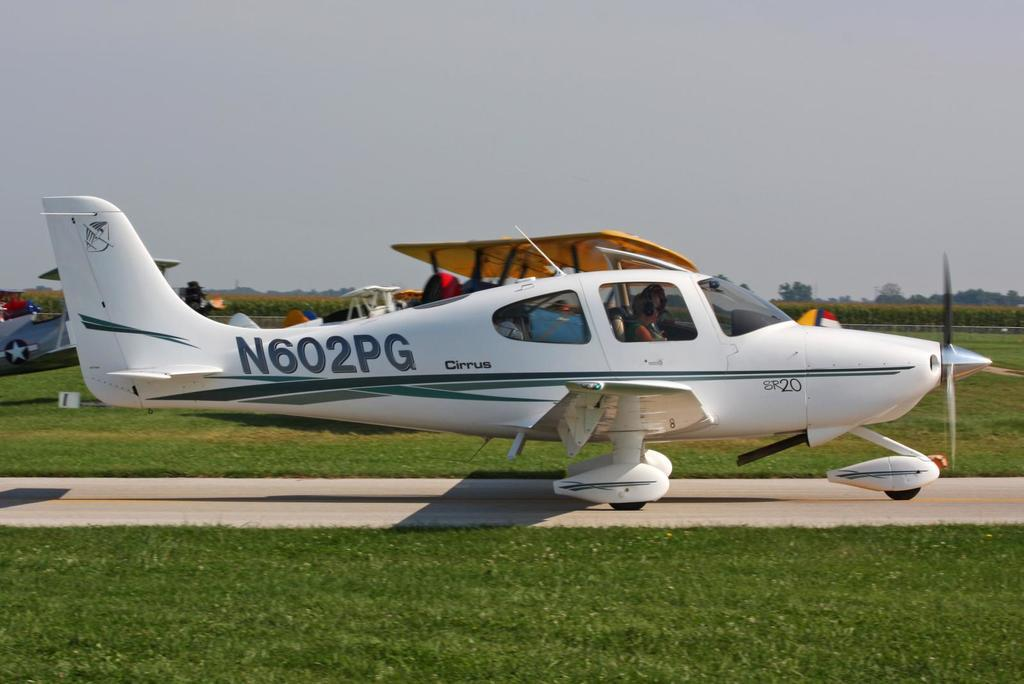What can be seen on the runway in the image? There are aeroplanes on the runway in the image. What are the people in the image doing? There are persons sitting in the seats of one of the aeroplanes. What type of natural environment is visible in the background of the image? Trees and agricultural farms are visible in the background of the image. What is visible in the sky in the image? The sky is visible in the background of the image. What type of fork can be seen in the image? There is no fork present in the image; it features aeroplanes on a runway with people sitting inside. How does the brake work on the aeroplanes in the image? The image does not show the brakes or their functionality; it only shows the aeroplanes on the runway. 